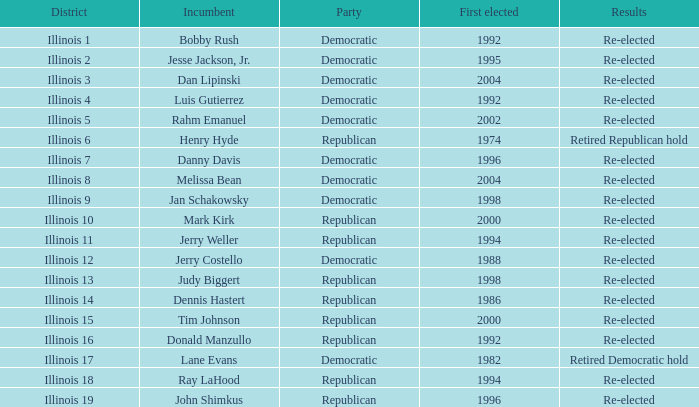What is the First Elected date of the Republican with Results of retired republican hold? 1974.0. 